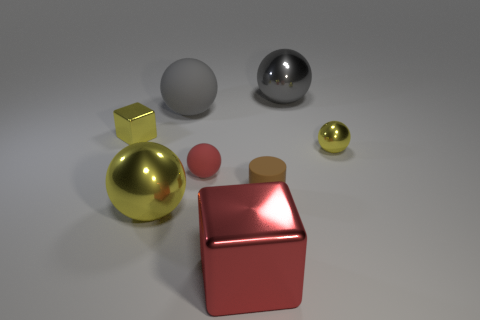Subtract all small balls. How many balls are left? 3 Subtract all brown blocks. How many yellow spheres are left? 2 Add 2 matte balls. How many objects exist? 10 Subtract all red balls. How many balls are left? 4 Subtract all cylinders. How many objects are left? 7 Subtract all gray balls. Subtract all brown cylinders. How many balls are left? 3 Subtract 0 purple cylinders. How many objects are left? 8 Subtract all blue spheres. Subtract all rubber objects. How many objects are left? 5 Add 2 big matte things. How many big matte things are left? 3 Add 6 brown cubes. How many brown cubes exist? 6 